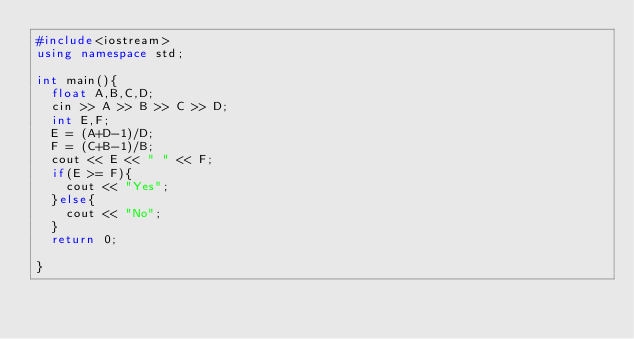<code> <loc_0><loc_0><loc_500><loc_500><_C++_>#include<iostream>
using namespace std;

int main(){
  float A,B,C,D;
  cin >> A >> B >> C >> D;
  int E,F;
  E = (A+D-1)/D;
  F = (C+B-1)/B;
  cout << E << " " << F;
  if(E >= F){
    cout << "Yes";
  }else{
    cout << "No";
  }
  return 0;

}
</code> 